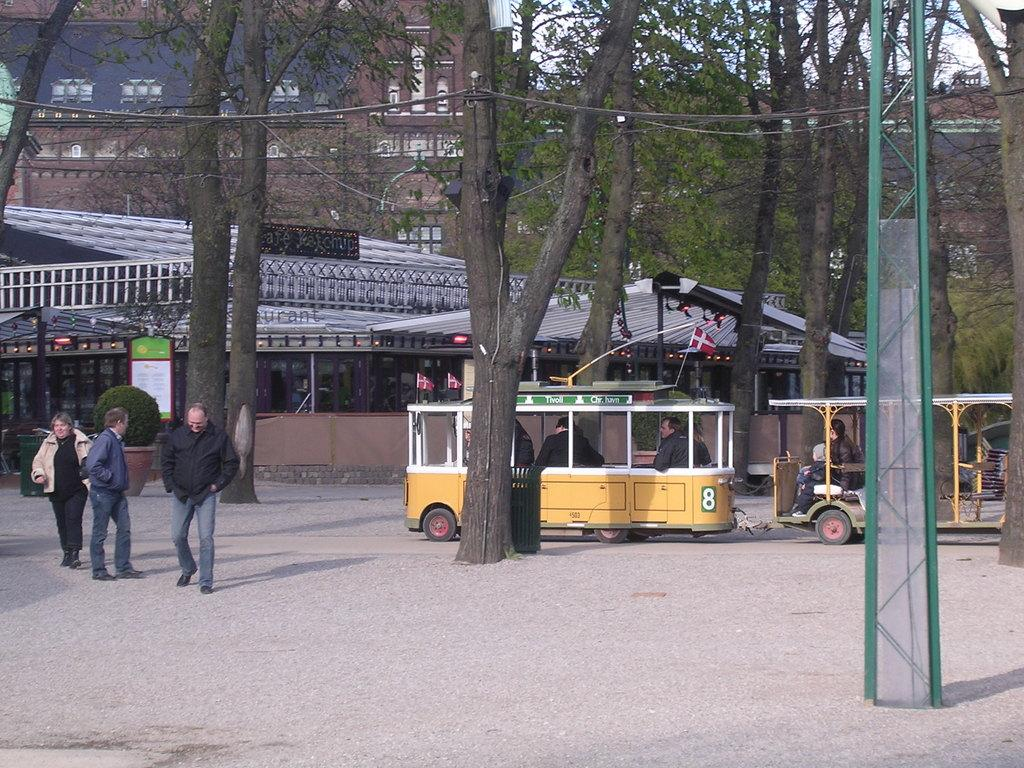<image>
Present a compact description of the photo's key features. A group of people walk past the yellow tram that is numbered 8. 